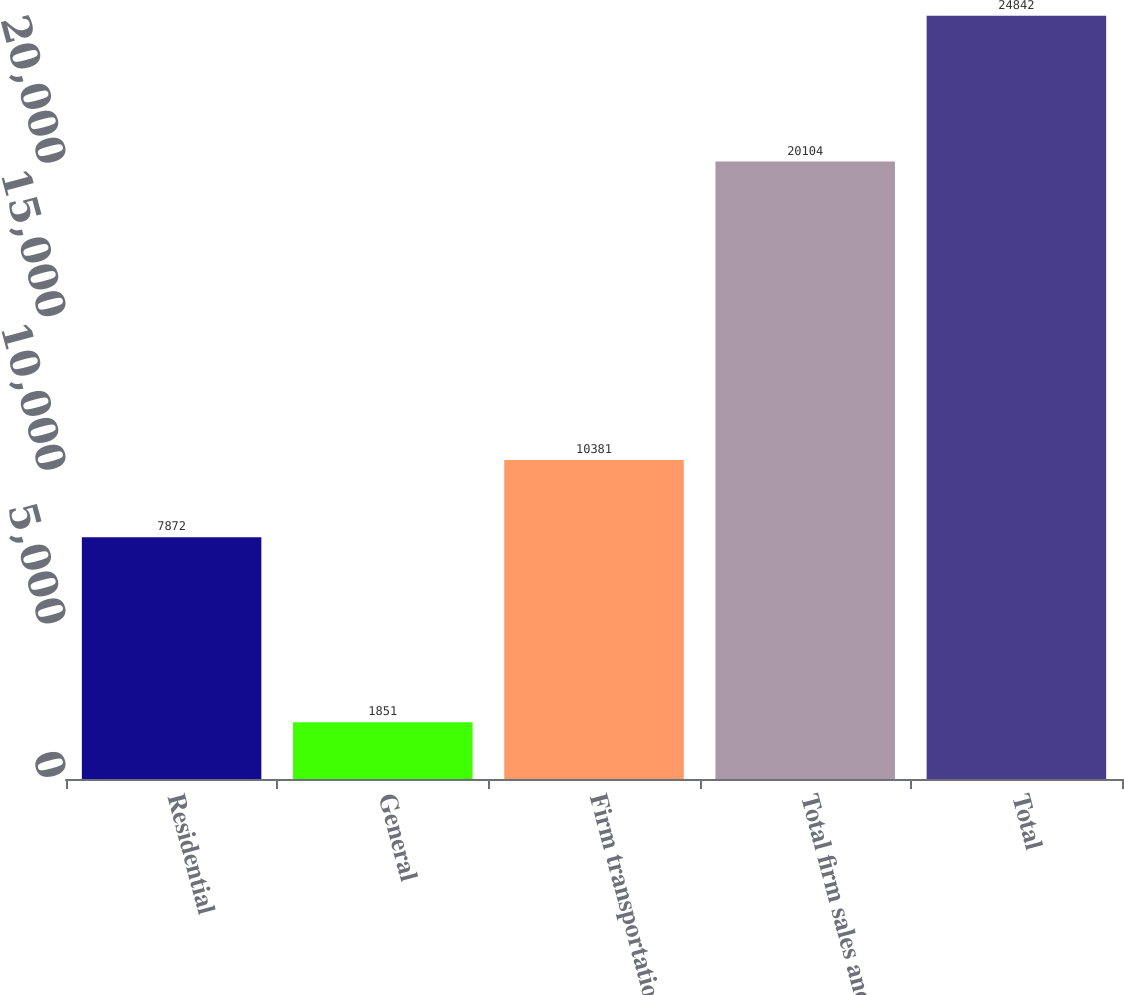Convert chart. <chart><loc_0><loc_0><loc_500><loc_500><bar_chart><fcel>Residential<fcel>General<fcel>Firm transportation<fcel>Total firm sales and<fcel>Total<nl><fcel>7872<fcel>1851<fcel>10381<fcel>20104<fcel>24842<nl></chart> 